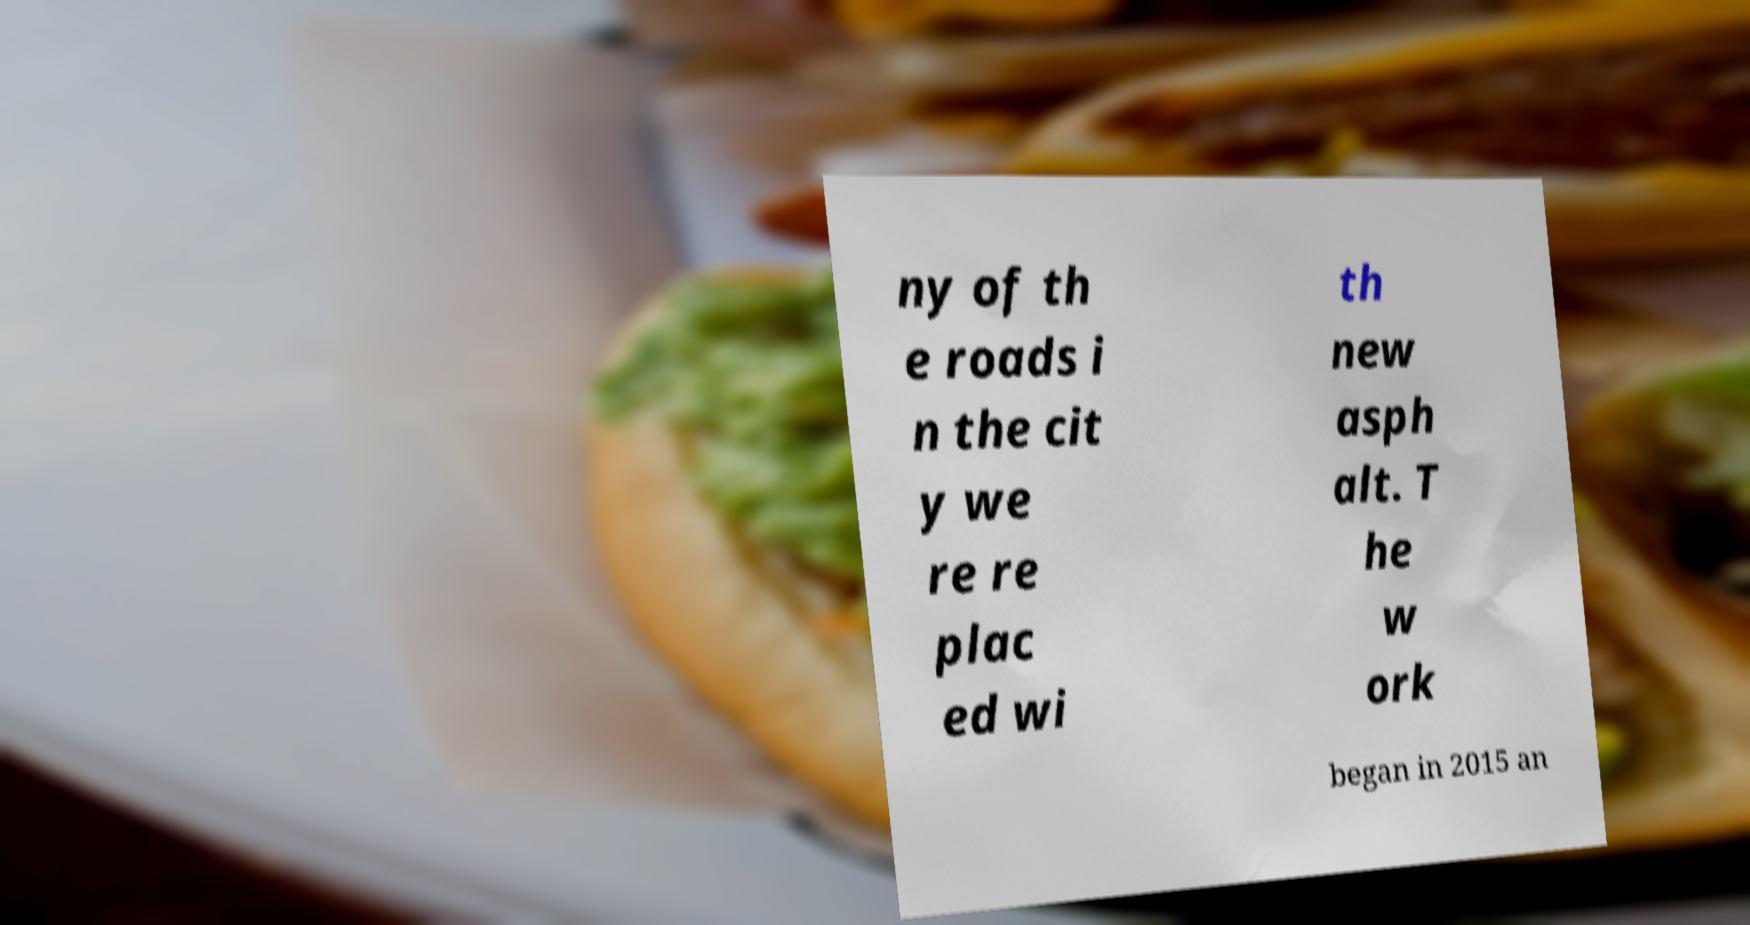Please identify and transcribe the text found in this image. ny of th e roads i n the cit y we re re plac ed wi th new asph alt. T he w ork began in 2015 an 